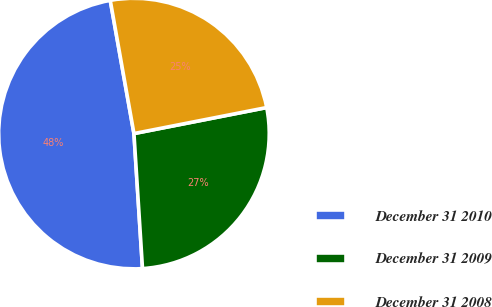<chart> <loc_0><loc_0><loc_500><loc_500><pie_chart><fcel>December 31 2010<fcel>December 31 2009<fcel>December 31 2008<nl><fcel>48.2%<fcel>27.07%<fcel>24.72%<nl></chart> 